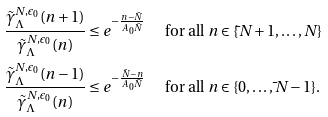Convert formula to latex. <formula><loc_0><loc_0><loc_500><loc_500>\frac { \tilde { \gamma } _ { \Lambda } ^ { N , \epsilon _ { 0 } } ( n + 1 ) } { \tilde { \gamma } _ { \Lambda } ^ { N , \epsilon _ { 0 } } ( n ) } & \leq e ^ { - \frac { n - \bar { N } } { A _ { 0 } \bar { N } } } \quad \ \, \text {for all $n\in\{\bar{ }N+1,\dots,N\}$} \\ \frac { \tilde { \gamma } _ { \Lambda } ^ { N , \epsilon _ { 0 } } ( n - 1 ) } { \tilde { \gamma } _ { \Lambda } ^ { N , \epsilon _ { 0 } } ( n ) } & \leq e ^ { - \frac { \bar { N } - n } { A _ { 0 } \bar { N } } } \quad \ \, \text {for all $n\in\{0,\dots,\bar{ }N-1\}$.}</formula> 